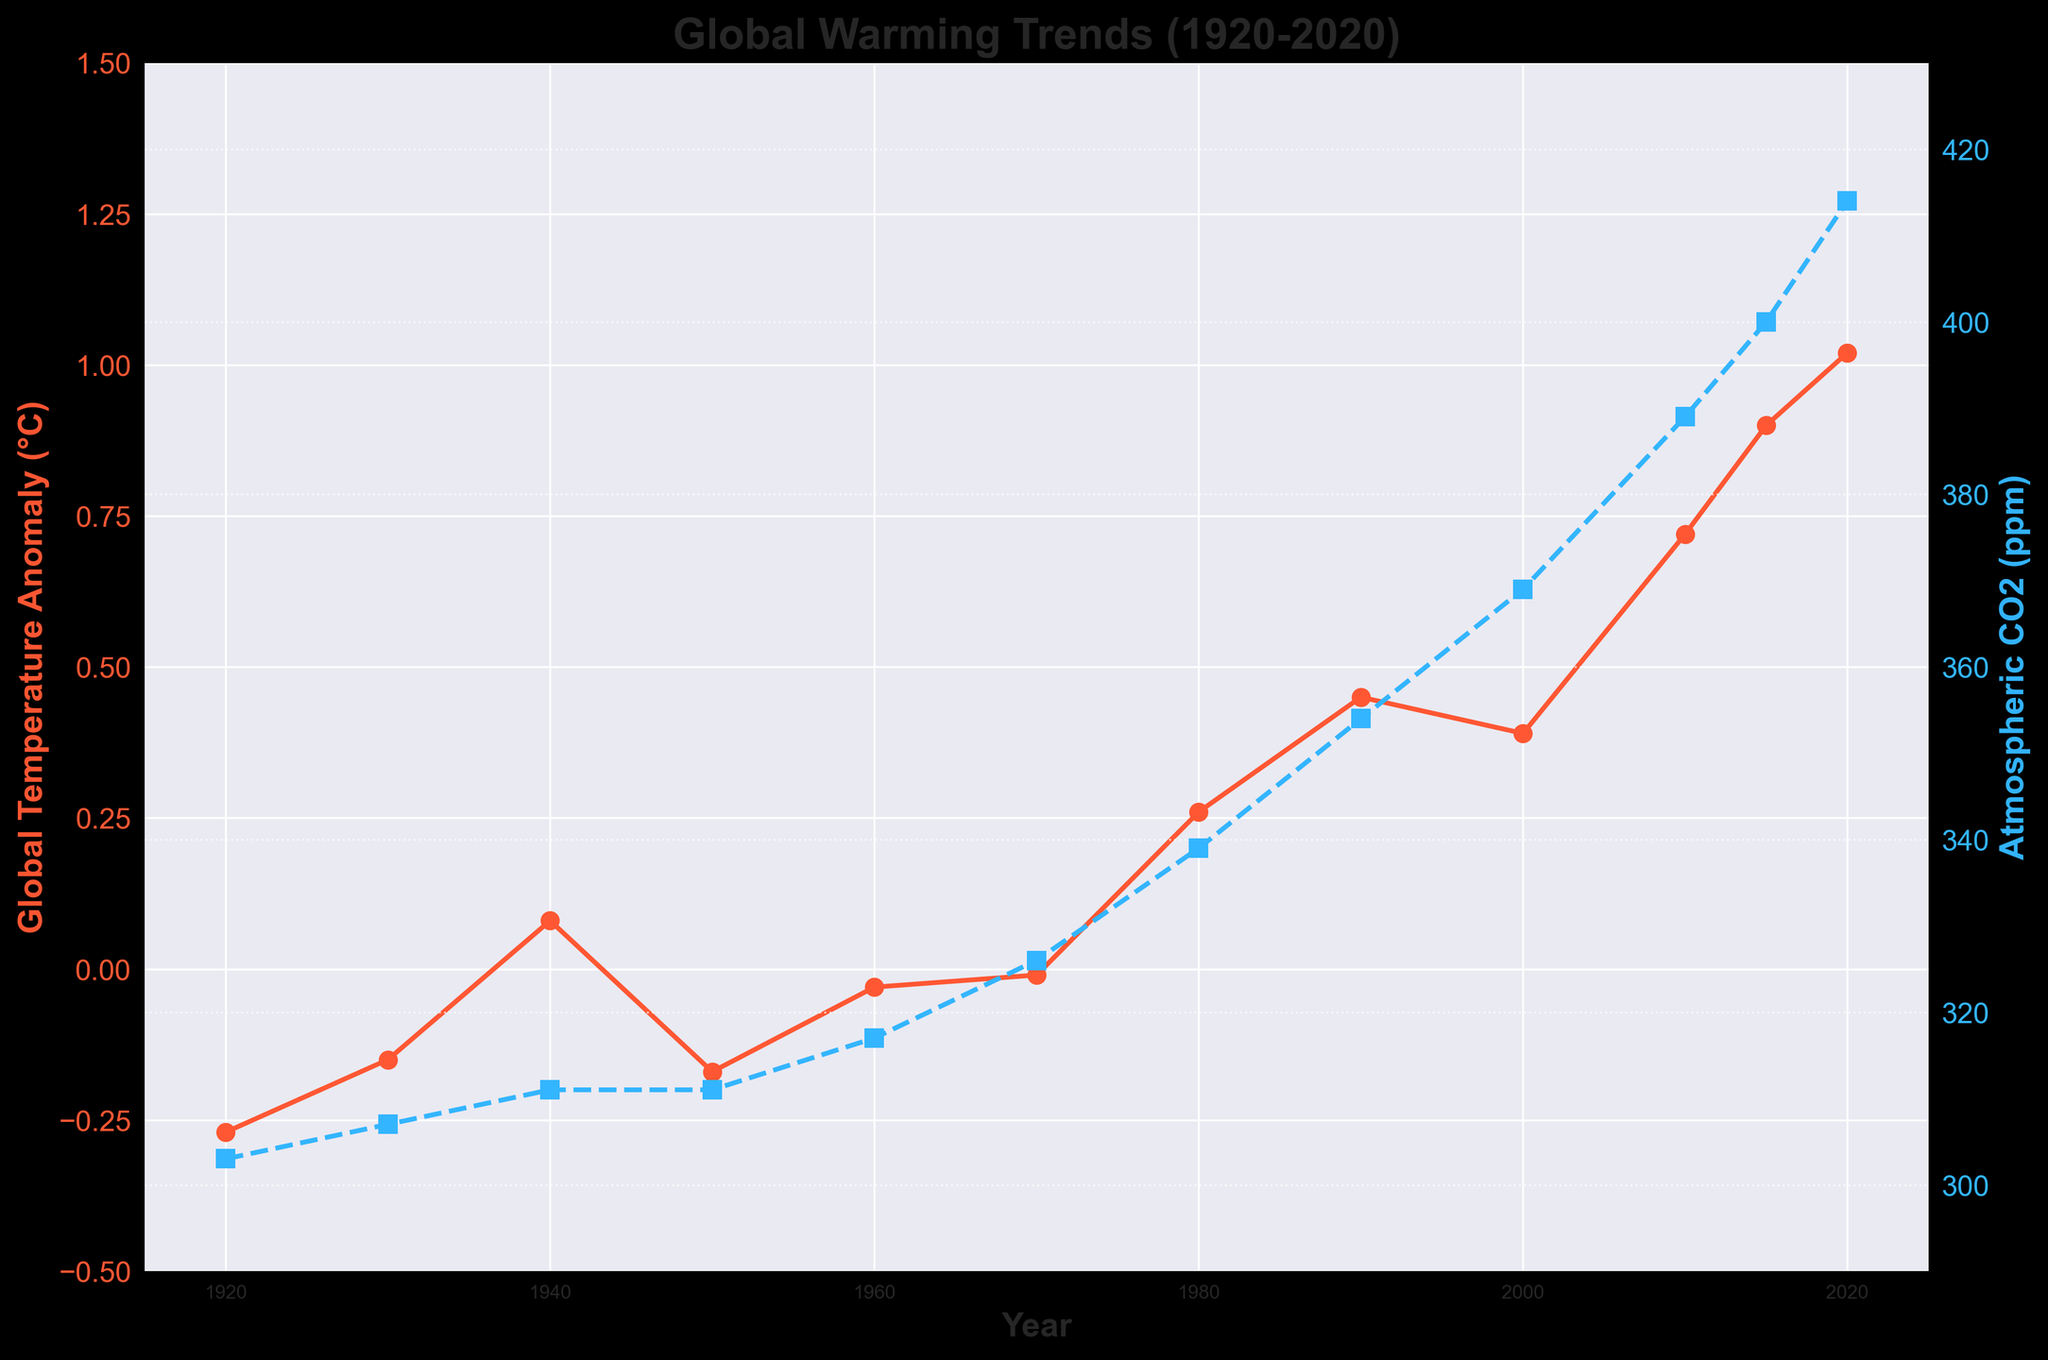What was the global temperature anomaly in 1920? The global temperature anomaly in 1920 is directly shown on the line chart, marked with a red circle.
Answer: -0.27°C What is the general trend of atmospheric CO2 levels from 1920 to 2020? Observing the blue dashed line, atmospheric CO2 levels have increased consistently from 303 ppm in 1920 to 414 ppm in 2020.
Answer: Increasing Which year had the highest global temperature anomaly? The highest point on the red line represents the year with the highest global temperature anomaly, which corresponds to 2020.
Answer: 2020 How much did the global temperature anomaly increase from 1950 to 2020? The global temperature anomaly in 1950 was -0.17°C and in 2020 it was 1.02°C. The increase is 1.02°C - (-0.17°C) = 1.19°C.
Answer: 1.19°C Is there a year when both the global temperature anomaly and atmospheric CO2 levels stayed constant compared to the previous decade? The global temperature anomaly values remained the same between 1930-1940 and 1940-1950, and atmospheric CO2 stayed the same between 1940-1950. Therefore, around 1940-1950 both values show constancy.
Answer: Around 1940-1950 How many years after 1960 did the global temperature anomaly become consistently positive? From the graph, the global temperature anomaly becomes consistently positive from 1980 onwards. From 1960 to 1980 is 20 years.
Answer: 20 years Which year had a lower global temperature anomaly but higher atmospheric CO2 level compared to 1980? By comparing the values, 2000 had a lower global temperature anomaly (0.39°C) but a higher atmospheric CO2 level (369 ppm) compared to 1980 (0.26°C, 339 ppm).
Answer: 2000 Between which years did the atmospheric CO2 levels cross 350 ppm? By observing the blue dashed line, atmospheric CO2 levels crossed 350 ppm between 1980 and 1990.
Answer: Between 1980 and 1990 Compare the rate of increase of global temperature anomaly and atmospheric CO2 levels from 1980 to 2000. From 1980 to 2000, the global temperature anomaly increased from 0.26°C to 0.39°C (an increase of 0.13°C), while atmospheric CO2 levels increased from 339 ppm to 369 ppm (an increase of 30 ppm).
Answer: CO2 rate is faster 